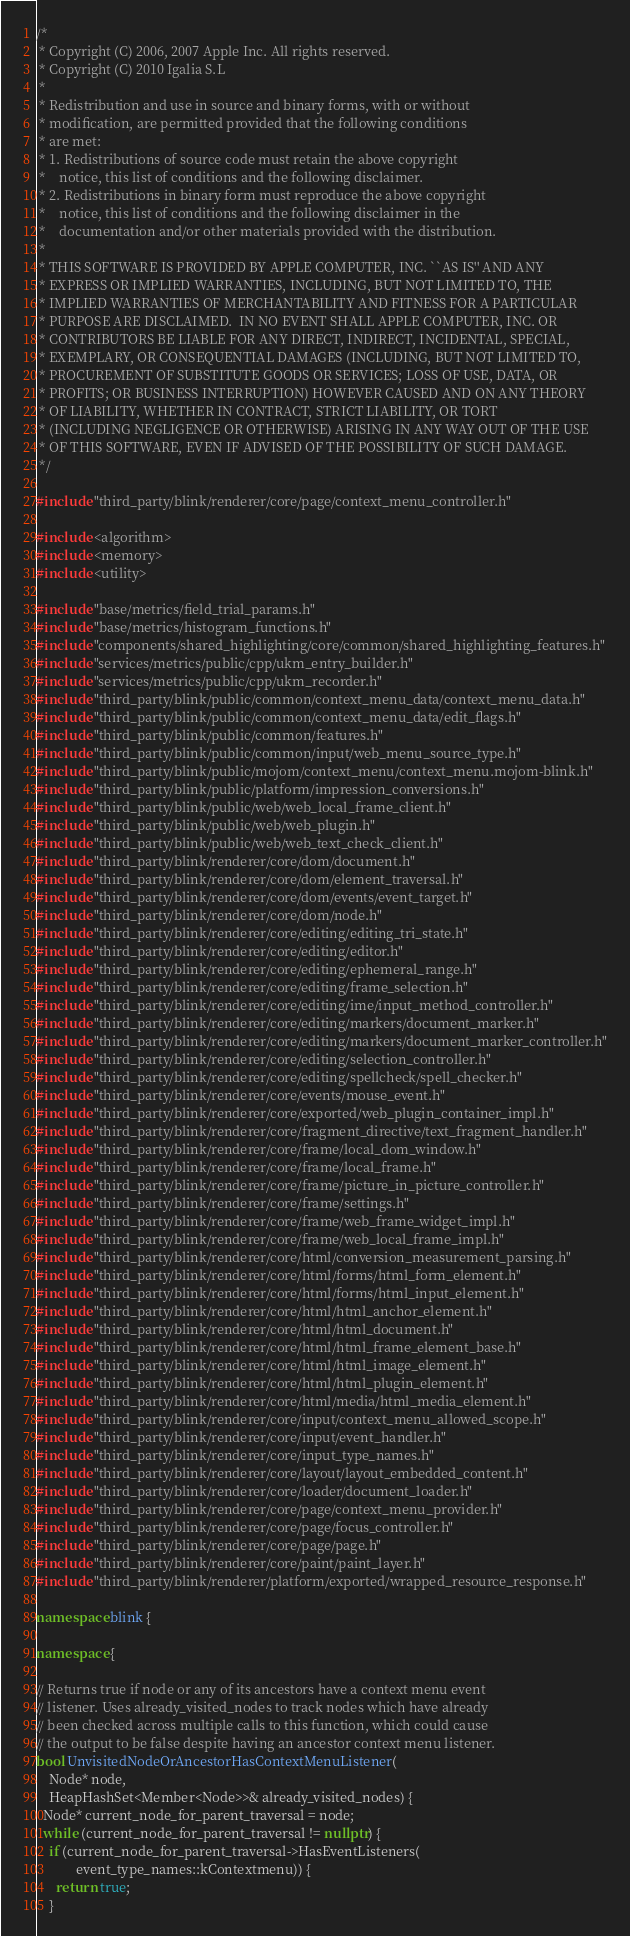<code> <loc_0><loc_0><loc_500><loc_500><_C++_>/*
 * Copyright (C) 2006, 2007 Apple Inc. All rights reserved.
 * Copyright (C) 2010 Igalia S.L
 *
 * Redistribution and use in source and binary forms, with or without
 * modification, are permitted provided that the following conditions
 * are met:
 * 1. Redistributions of source code must retain the above copyright
 *    notice, this list of conditions and the following disclaimer.
 * 2. Redistributions in binary form must reproduce the above copyright
 *    notice, this list of conditions and the following disclaimer in the
 *    documentation and/or other materials provided with the distribution.
 *
 * THIS SOFTWARE IS PROVIDED BY APPLE COMPUTER, INC. ``AS IS'' AND ANY
 * EXPRESS OR IMPLIED WARRANTIES, INCLUDING, BUT NOT LIMITED TO, THE
 * IMPLIED WARRANTIES OF MERCHANTABILITY AND FITNESS FOR A PARTICULAR
 * PURPOSE ARE DISCLAIMED.  IN NO EVENT SHALL APPLE COMPUTER, INC. OR
 * CONTRIBUTORS BE LIABLE FOR ANY DIRECT, INDIRECT, INCIDENTAL, SPECIAL,
 * EXEMPLARY, OR CONSEQUENTIAL DAMAGES (INCLUDING, BUT NOT LIMITED TO,
 * PROCUREMENT OF SUBSTITUTE GOODS OR SERVICES; LOSS OF USE, DATA, OR
 * PROFITS; OR BUSINESS INTERRUPTION) HOWEVER CAUSED AND ON ANY THEORY
 * OF LIABILITY, WHETHER IN CONTRACT, STRICT LIABILITY, OR TORT
 * (INCLUDING NEGLIGENCE OR OTHERWISE) ARISING IN ANY WAY OUT OF THE USE
 * OF THIS SOFTWARE, EVEN IF ADVISED OF THE POSSIBILITY OF SUCH DAMAGE.
 */

#include "third_party/blink/renderer/core/page/context_menu_controller.h"

#include <algorithm>
#include <memory>
#include <utility>

#include "base/metrics/field_trial_params.h"
#include "base/metrics/histogram_functions.h"
#include "components/shared_highlighting/core/common/shared_highlighting_features.h"
#include "services/metrics/public/cpp/ukm_entry_builder.h"
#include "services/metrics/public/cpp/ukm_recorder.h"
#include "third_party/blink/public/common/context_menu_data/context_menu_data.h"
#include "third_party/blink/public/common/context_menu_data/edit_flags.h"
#include "third_party/blink/public/common/features.h"
#include "third_party/blink/public/common/input/web_menu_source_type.h"
#include "third_party/blink/public/mojom/context_menu/context_menu.mojom-blink.h"
#include "third_party/blink/public/platform/impression_conversions.h"
#include "third_party/blink/public/web/web_local_frame_client.h"
#include "third_party/blink/public/web/web_plugin.h"
#include "third_party/blink/public/web/web_text_check_client.h"
#include "third_party/blink/renderer/core/dom/document.h"
#include "third_party/blink/renderer/core/dom/element_traversal.h"
#include "third_party/blink/renderer/core/dom/events/event_target.h"
#include "third_party/blink/renderer/core/dom/node.h"
#include "third_party/blink/renderer/core/editing/editing_tri_state.h"
#include "third_party/blink/renderer/core/editing/editor.h"
#include "third_party/blink/renderer/core/editing/ephemeral_range.h"
#include "third_party/blink/renderer/core/editing/frame_selection.h"
#include "third_party/blink/renderer/core/editing/ime/input_method_controller.h"
#include "third_party/blink/renderer/core/editing/markers/document_marker.h"
#include "third_party/blink/renderer/core/editing/markers/document_marker_controller.h"
#include "third_party/blink/renderer/core/editing/selection_controller.h"
#include "third_party/blink/renderer/core/editing/spellcheck/spell_checker.h"
#include "third_party/blink/renderer/core/events/mouse_event.h"
#include "third_party/blink/renderer/core/exported/web_plugin_container_impl.h"
#include "third_party/blink/renderer/core/fragment_directive/text_fragment_handler.h"
#include "third_party/blink/renderer/core/frame/local_dom_window.h"
#include "third_party/blink/renderer/core/frame/local_frame.h"
#include "third_party/blink/renderer/core/frame/picture_in_picture_controller.h"
#include "third_party/blink/renderer/core/frame/settings.h"
#include "third_party/blink/renderer/core/frame/web_frame_widget_impl.h"
#include "third_party/blink/renderer/core/frame/web_local_frame_impl.h"
#include "third_party/blink/renderer/core/html/conversion_measurement_parsing.h"
#include "third_party/blink/renderer/core/html/forms/html_form_element.h"
#include "third_party/blink/renderer/core/html/forms/html_input_element.h"
#include "third_party/blink/renderer/core/html/html_anchor_element.h"
#include "third_party/blink/renderer/core/html/html_document.h"
#include "third_party/blink/renderer/core/html/html_frame_element_base.h"
#include "third_party/blink/renderer/core/html/html_image_element.h"
#include "third_party/blink/renderer/core/html/html_plugin_element.h"
#include "third_party/blink/renderer/core/html/media/html_media_element.h"
#include "third_party/blink/renderer/core/input/context_menu_allowed_scope.h"
#include "third_party/blink/renderer/core/input/event_handler.h"
#include "third_party/blink/renderer/core/input_type_names.h"
#include "third_party/blink/renderer/core/layout/layout_embedded_content.h"
#include "third_party/blink/renderer/core/loader/document_loader.h"
#include "third_party/blink/renderer/core/page/context_menu_provider.h"
#include "third_party/blink/renderer/core/page/focus_controller.h"
#include "third_party/blink/renderer/core/page/page.h"
#include "third_party/blink/renderer/core/paint/paint_layer.h"
#include "third_party/blink/renderer/platform/exported/wrapped_resource_response.h"

namespace blink {

namespace {

// Returns true if node or any of its ancestors have a context menu event
// listener. Uses already_visited_nodes to track nodes which have already
// been checked across multiple calls to this function, which could cause
// the output to be false despite having an ancestor context menu listener.
bool UnvisitedNodeOrAncestorHasContextMenuListener(
    Node* node,
    HeapHashSet<Member<Node>>& already_visited_nodes) {
  Node* current_node_for_parent_traversal = node;
  while (current_node_for_parent_traversal != nullptr) {
    if (current_node_for_parent_traversal->HasEventListeners(
            event_type_names::kContextmenu)) {
      return true;
    }</code> 